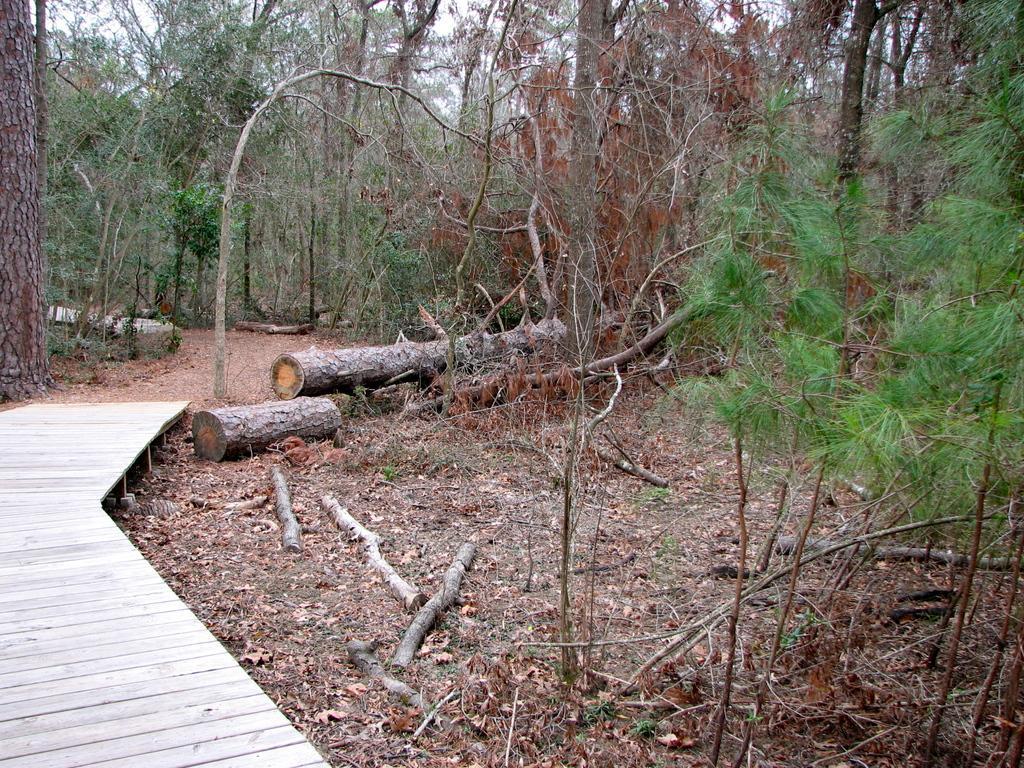Can you describe this image briefly? In this picture there is a view of the forest. In the front there is a wooden trunks. On the left side there is a small wooden bridge. 